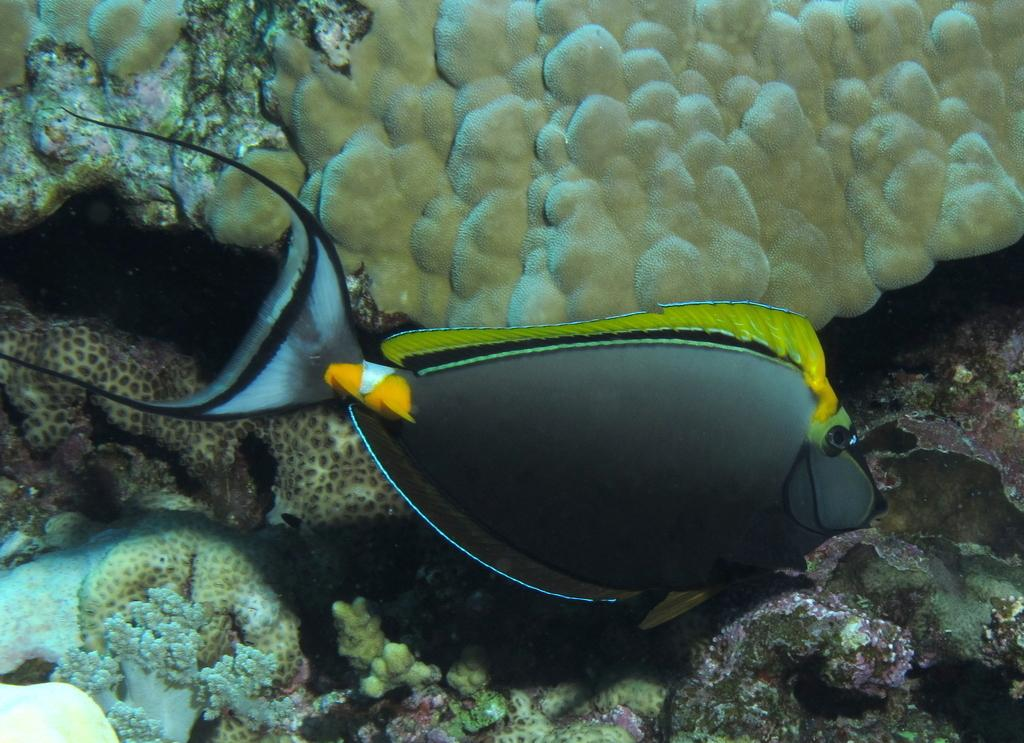What type of animals can be seen in the image? There are fish in the image. What type of underwater environment is visible in the image? There are coral reefs in the image. Where is the scene of the image taking place? The scene is underwater. What type of hat is the fish wearing in the image? There are no hats present in the image, as the scene is underwater and fish do not wear hats. 